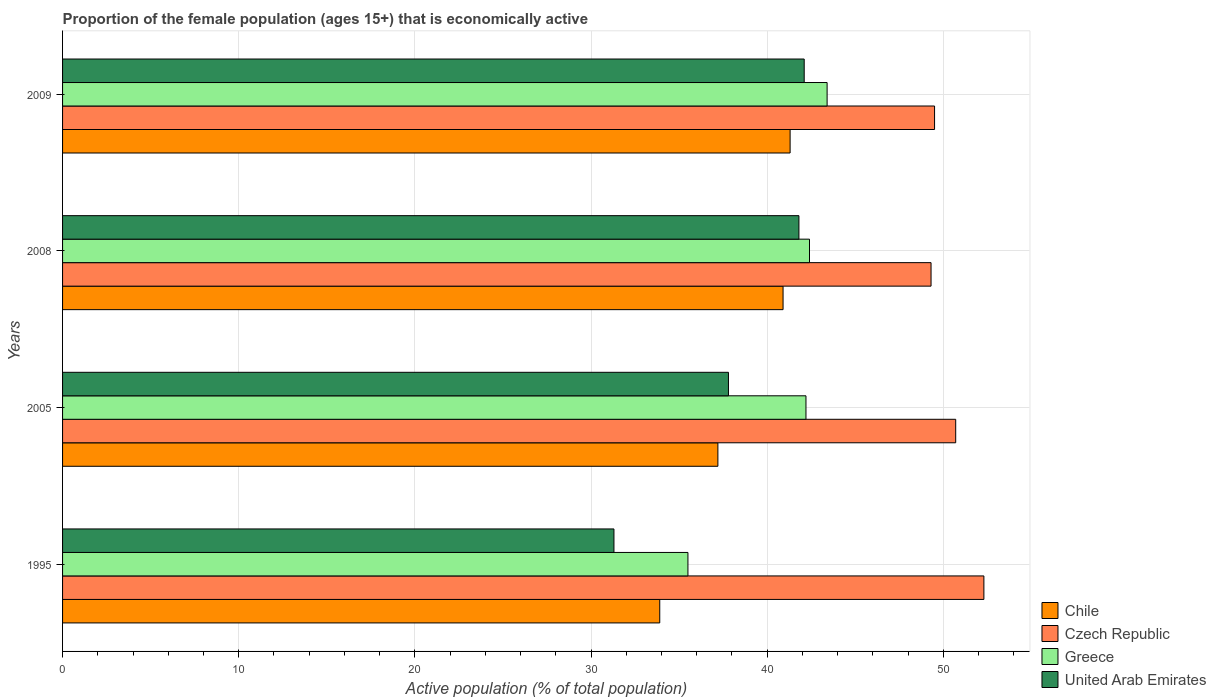How many groups of bars are there?
Offer a very short reply. 4. Are the number of bars on each tick of the Y-axis equal?
Give a very brief answer. Yes. How many bars are there on the 3rd tick from the top?
Provide a succinct answer. 4. What is the label of the 3rd group of bars from the top?
Provide a short and direct response. 2005. In how many cases, is the number of bars for a given year not equal to the number of legend labels?
Give a very brief answer. 0. What is the proportion of the female population that is economically active in Czech Republic in 2009?
Keep it short and to the point. 49.5. Across all years, what is the maximum proportion of the female population that is economically active in United Arab Emirates?
Ensure brevity in your answer.  42.1. Across all years, what is the minimum proportion of the female population that is economically active in United Arab Emirates?
Give a very brief answer. 31.3. In which year was the proportion of the female population that is economically active in United Arab Emirates minimum?
Offer a very short reply. 1995. What is the total proportion of the female population that is economically active in Chile in the graph?
Make the answer very short. 153.3. What is the difference between the proportion of the female population that is economically active in Greece in 1995 and that in 2009?
Provide a short and direct response. -7.9. What is the difference between the proportion of the female population that is economically active in United Arab Emirates in 2005 and the proportion of the female population that is economically active in Greece in 2009?
Ensure brevity in your answer.  -5.6. What is the average proportion of the female population that is economically active in Greece per year?
Keep it short and to the point. 40.88. In the year 1995, what is the difference between the proportion of the female population that is economically active in Chile and proportion of the female population that is economically active in Czech Republic?
Your answer should be very brief. -18.4. In how many years, is the proportion of the female population that is economically active in Chile greater than 52 %?
Make the answer very short. 0. What is the ratio of the proportion of the female population that is economically active in Czech Republic in 1995 to that in 2008?
Ensure brevity in your answer.  1.06. Is the proportion of the female population that is economically active in United Arab Emirates in 2005 less than that in 2008?
Provide a short and direct response. Yes. What is the difference between the highest and the second highest proportion of the female population that is economically active in Czech Republic?
Give a very brief answer. 1.6. What is the difference between the highest and the lowest proportion of the female population that is economically active in Czech Republic?
Make the answer very short. 3. Is it the case that in every year, the sum of the proportion of the female population that is economically active in United Arab Emirates and proportion of the female population that is economically active in Greece is greater than the sum of proportion of the female population that is economically active in Chile and proportion of the female population that is economically active in Czech Republic?
Your answer should be compact. No. What does the 4th bar from the top in 1995 represents?
Give a very brief answer. Chile. Is it the case that in every year, the sum of the proportion of the female population that is economically active in Chile and proportion of the female population that is economically active in Greece is greater than the proportion of the female population that is economically active in United Arab Emirates?
Keep it short and to the point. Yes. How many bars are there?
Provide a short and direct response. 16. Are all the bars in the graph horizontal?
Give a very brief answer. Yes. How many years are there in the graph?
Provide a short and direct response. 4. What is the difference between two consecutive major ticks on the X-axis?
Make the answer very short. 10. Are the values on the major ticks of X-axis written in scientific E-notation?
Provide a short and direct response. No. Where does the legend appear in the graph?
Offer a terse response. Bottom right. How many legend labels are there?
Your answer should be very brief. 4. How are the legend labels stacked?
Give a very brief answer. Vertical. What is the title of the graph?
Offer a terse response. Proportion of the female population (ages 15+) that is economically active. Does "Congo (Democratic)" appear as one of the legend labels in the graph?
Provide a succinct answer. No. What is the label or title of the X-axis?
Your answer should be very brief. Active population (% of total population). What is the Active population (% of total population) of Chile in 1995?
Your response must be concise. 33.9. What is the Active population (% of total population) in Czech Republic in 1995?
Give a very brief answer. 52.3. What is the Active population (% of total population) of Greece in 1995?
Offer a terse response. 35.5. What is the Active population (% of total population) in United Arab Emirates in 1995?
Offer a very short reply. 31.3. What is the Active population (% of total population) in Chile in 2005?
Provide a succinct answer. 37.2. What is the Active population (% of total population) in Czech Republic in 2005?
Your response must be concise. 50.7. What is the Active population (% of total population) of Greece in 2005?
Make the answer very short. 42.2. What is the Active population (% of total population) in United Arab Emirates in 2005?
Make the answer very short. 37.8. What is the Active population (% of total population) in Chile in 2008?
Your answer should be very brief. 40.9. What is the Active population (% of total population) of Czech Republic in 2008?
Offer a terse response. 49.3. What is the Active population (% of total population) of Greece in 2008?
Provide a short and direct response. 42.4. What is the Active population (% of total population) in United Arab Emirates in 2008?
Keep it short and to the point. 41.8. What is the Active population (% of total population) of Chile in 2009?
Make the answer very short. 41.3. What is the Active population (% of total population) of Czech Republic in 2009?
Offer a very short reply. 49.5. What is the Active population (% of total population) in Greece in 2009?
Your response must be concise. 43.4. What is the Active population (% of total population) of United Arab Emirates in 2009?
Give a very brief answer. 42.1. Across all years, what is the maximum Active population (% of total population) of Chile?
Provide a short and direct response. 41.3. Across all years, what is the maximum Active population (% of total population) in Czech Republic?
Provide a short and direct response. 52.3. Across all years, what is the maximum Active population (% of total population) of Greece?
Your answer should be compact. 43.4. Across all years, what is the maximum Active population (% of total population) of United Arab Emirates?
Your answer should be compact. 42.1. Across all years, what is the minimum Active population (% of total population) in Chile?
Make the answer very short. 33.9. Across all years, what is the minimum Active population (% of total population) of Czech Republic?
Your response must be concise. 49.3. Across all years, what is the minimum Active population (% of total population) of Greece?
Offer a very short reply. 35.5. Across all years, what is the minimum Active population (% of total population) of United Arab Emirates?
Give a very brief answer. 31.3. What is the total Active population (% of total population) in Chile in the graph?
Offer a very short reply. 153.3. What is the total Active population (% of total population) of Czech Republic in the graph?
Give a very brief answer. 201.8. What is the total Active population (% of total population) in Greece in the graph?
Provide a short and direct response. 163.5. What is the total Active population (% of total population) in United Arab Emirates in the graph?
Offer a terse response. 153. What is the difference between the Active population (% of total population) of Czech Republic in 1995 and that in 2005?
Ensure brevity in your answer.  1.6. What is the difference between the Active population (% of total population) in Czech Republic in 1995 and that in 2008?
Provide a short and direct response. 3. What is the difference between the Active population (% of total population) of United Arab Emirates in 1995 and that in 2008?
Offer a terse response. -10.5. What is the difference between the Active population (% of total population) in Chile in 1995 and that in 2009?
Offer a terse response. -7.4. What is the difference between the Active population (% of total population) of Czech Republic in 1995 and that in 2009?
Provide a succinct answer. 2.8. What is the difference between the Active population (% of total population) of United Arab Emirates in 1995 and that in 2009?
Give a very brief answer. -10.8. What is the difference between the Active population (% of total population) in Czech Republic in 2005 and that in 2008?
Your response must be concise. 1.4. What is the difference between the Active population (% of total population) in United Arab Emirates in 2005 and that in 2008?
Your answer should be very brief. -4. What is the difference between the Active population (% of total population) in Chile in 2008 and that in 2009?
Offer a terse response. -0.4. What is the difference between the Active population (% of total population) in Chile in 1995 and the Active population (% of total population) in Czech Republic in 2005?
Your answer should be very brief. -16.8. What is the difference between the Active population (% of total population) of Chile in 1995 and the Active population (% of total population) of Greece in 2005?
Offer a terse response. -8.3. What is the difference between the Active population (% of total population) of Czech Republic in 1995 and the Active population (% of total population) of Greece in 2005?
Provide a short and direct response. 10.1. What is the difference between the Active population (% of total population) of Chile in 1995 and the Active population (% of total population) of Czech Republic in 2008?
Your answer should be compact. -15.4. What is the difference between the Active population (% of total population) of Chile in 1995 and the Active population (% of total population) of Greece in 2008?
Offer a terse response. -8.5. What is the difference between the Active population (% of total population) in Chile in 1995 and the Active population (% of total population) in United Arab Emirates in 2008?
Provide a succinct answer. -7.9. What is the difference between the Active population (% of total population) of Czech Republic in 1995 and the Active population (% of total population) of United Arab Emirates in 2008?
Your answer should be very brief. 10.5. What is the difference between the Active population (% of total population) of Chile in 1995 and the Active population (% of total population) of Czech Republic in 2009?
Keep it short and to the point. -15.6. What is the difference between the Active population (% of total population) in Czech Republic in 1995 and the Active population (% of total population) in Greece in 2009?
Your answer should be very brief. 8.9. What is the difference between the Active population (% of total population) of Czech Republic in 1995 and the Active population (% of total population) of United Arab Emirates in 2009?
Make the answer very short. 10.2. What is the difference between the Active population (% of total population) in Greece in 1995 and the Active population (% of total population) in United Arab Emirates in 2009?
Your answer should be compact. -6.6. What is the difference between the Active population (% of total population) of Chile in 2005 and the Active population (% of total population) of Czech Republic in 2008?
Your response must be concise. -12.1. What is the difference between the Active population (% of total population) in Chile in 2005 and the Active population (% of total population) in Czech Republic in 2009?
Your answer should be very brief. -12.3. What is the difference between the Active population (% of total population) in Chile in 2005 and the Active population (% of total population) in Greece in 2009?
Your response must be concise. -6.2. What is the difference between the Active population (% of total population) in Greece in 2005 and the Active population (% of total population) in United Arab Emirates in 2009?
Make the answer very short. 0.1. What is the difference between the Active population (% of total population) in Chile in 2008 and the Active population (% of total population) in Czech Republic in 2009?
Make the answer very short. -8.6. What is the average Active population (% of total population) in Chile per year?
Make the answer very short. 38.33. What is the average Active population (% of total population) of Czech Republic per year?
Your answer should be very brief. 50.45. What is the average Active population (% of total population) of Greece per year?
Give a very brief answer. 40.88. What is the average Active population (% of total population) in United Arab Emirates per year?
Make the answer very short. 38.25. In the year 1995, what is the difference between the Active population (% of total population) of Chile and Active population (% of total population) of Czech Republic?
Provide a succinct answer. -18.4. In the year 1995, what is the difference between the Active population (% of total population) of Chile and Active population (% of total population) of Greece?
Ensure brevity in your answer.  -1.6. In the year 1995, what is the difference between the Active population (% of total population) in Chile and Active population (% of total population) in United Arab Emirates?
Provide a short and direct response. 2.6. In the year 1995, what is the difference between the Active population (% of total population) in Czech Republic and Active population (% of total population) in Greece?
Offer a terse response. 16.8. In the year 1995, what is the difference between the Active population (% of total population) in Greece and Active population (% of total population) in United Arab Emirates?
Offer a terse response. 4.2. In the year 2005, what is the difference between the Active population (% of total population) of Czech Republic and Active population (% of total population) of Greece?
Keep it short and to the point. 8.5. In the year 2005, what is the difference between the Active population (% of total population) in Greece and Active population (% of total population) in United Arab Emirates?
Give a very brief answer. 4.4. In the year 2008, what is the difference between the Active population (% of total population) of Chile and Active population (% of total population) of Czech Republic?
Provide a succinct answer. -8.4. In the year 2008, what is the difference between the Active population (% of total population) of Chile and Active population (% of total population) of Greece?
Your answer should be very brief. -1.5. In the year 2008, what is the difference between the Active population (% of total population) in Czech Republic and Active population (% of total population) in United Arab Emirates?
Provide a succinct answer. 7.5. In the year 2008, what is the difference between the Active population (% of total population) of Greece and Active population (% of total population) of United Arab Emirates?
Offer a terse response. 0.6. In the year 2009, what is the difference between the Active population (% of total population) of Chile and Active population (% of total population) of United Arab Emirates?
Offer a very short reply. -0.8. In the year 2009, what is the difference between the Active population (% of total population) in Czech Republic and Active population (% of total population) in Greece?
Offer a terse response. 6.1. In the year 2009, what is the difference between the Active population (% of total population) of Greece and Active population (% of total population) of United Arab Emirates?
Offer a terse response. 1.3. What is the ratio of the Active population (% of total population) in Chile in 1995 to that in 2005?
Offer a very short reply. 0.91. What is the ratio of the Active population (% of total population) in Czech Republic in 1995 to that in 2005?
Your answer should be very brief. 1.03. What is the ratio of the Active population (% of total population) of Greece in 1995 to that in 2005?
Your answer should be very brief. 0.84. What is the ratio of the Active population (% of total population) of United Arab Emirates in 1995 to that in 2005?
Provide a short and direct response. 0.83. What is the ratio of the Active population (% of total population) in Chile in 1995 to that in 2008?
Provide a succinct answer. 0.83. What is the ratio of the Active population (% of total population) in Czech Republic in 1995 to that in 2008?
Provide a short and direct response. 1.06. What is the ratio of the Active population (% of total population) of Greece in 1995 to that in 2008?
Provide a succinct answer. 0.84. What is the ratio of the Active population (% of total population) in United Arab Emirates in 1995 to that in 2008?
Offer a very short reply. 0.75. What is the ratio of the Active population (% of total population) of Chile in 1995 to that in 2009?
Your answer should be very brief. 0.82. What is the ratio of the Active population (% of total population) in Czech Republic in 1995 to that in 2009?
Make the answer very short. 1.06. What is the ratio of the Active population (% of total population) of Greece in 1995 to that in 2009?
Your response must be concise. 0.82. What is the ratio of the Active population (% of total population) of United Arab Emirates in 1995 to that in 2009?
Ensure brevity in your answer.  0.74. What is the ratio of the Active population (% of total population) in Chile in 2005 to that in 2008?
Give a very brief answer. 0.91. What is the ratio of the Active population (% of total population) in Czech Republic in 2005 to that in 2008?
Offer a terse response. 1.03. What is the ratio of the Active population (% of total population) of Greece in 2005 to that in 2008?
Offer a very short reply. 1. What is the ratio of the Active population (% of total population) in United Arab Emirates in 2005 to that in 2008?
Keep it short and to the point. 0.9. What is the ratio of the Active population (% of total population) of Chile in 2005 to that in 2009?
Offer a very short reply. 0.9. What is the ratio of the Active population (% of total population) in Czech Republic in 2005 to that in 2009?
Ensure brevity in your answer.  1.02. What is the ratio of the Active population (% of total population) in Greece in 2005 to that in 2009?
Make the answer very short. 0.97. What is the ratio of the Active population (% of total population) of United Arab Emirates in 2005 to that in 2009?
Ensure brevity in your answer.  0.9. What is the ratio of the Active population (% of total population) in Chile in 2008 to that in 2009?
Your answer should be very brief. 0.99. What is the ratio of the Active population (% of total population) of Czech Republic in 2008 to that in 2009?
Keep it short and to the point. 1. What is the difference between the highest and the second highest Active population (% of total population) of Czech Republic?
Provide a succinct answer. 1.6. What is the difference between the highest and the second highest Active population (% of total population) of Greece?
Give a very brief answer. 1. What is the difference between the highest and the lowest Active population (% of total population) in Czech Republic?
Offer a very short reply. 3. What is the difference between the highest and the lowest Active population (% of total population) of Greece?
Your answer should be compact. 7.9. What is the difference between the highest and the lowest Active population (% of total population) in United Arab Emirates?
Keep it short and to the point. 10.8. 